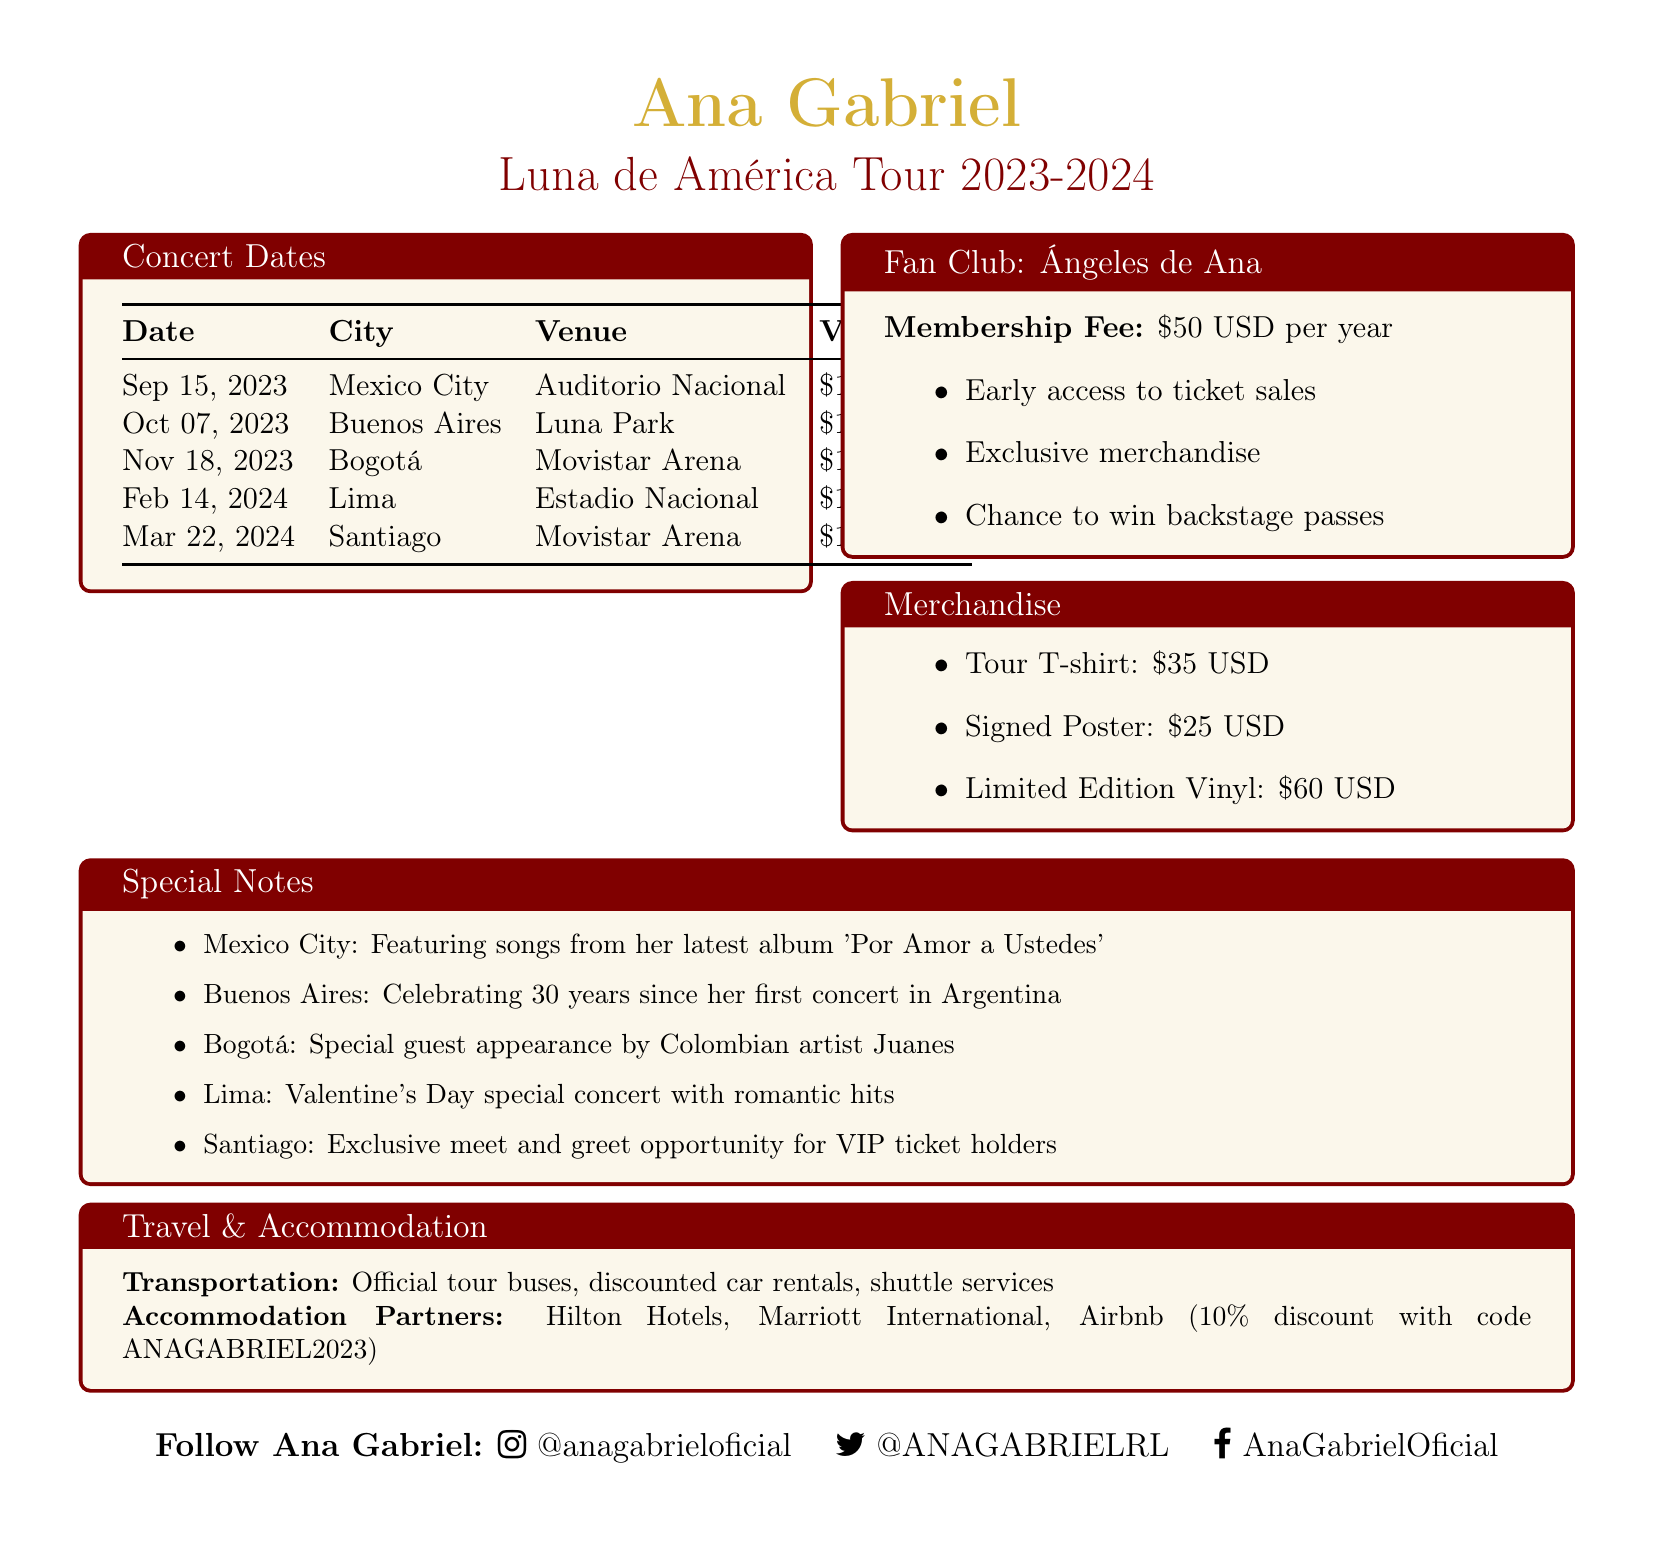What is the name of the tour? The tour is named "Luna de América Tour 2023-2024."
Answer: Luna de América Tour 2023-2024 When is the concert in Buenos Aires? The concert in Buenos Aires is scheduled for October 7, 2023.
Answer: October 7, 2023 What is the venue for the concert in Bogotá? The venue for the concert in Bogotá is "Movistar Arena."
Answer: Movistar Arena How much is a VIP ticket for the concert in Lima? The VIP ticket for the concert in Lima costs $140 USD.
Answer: $140 USD Which special guest will perform in Bogotá? The special guest in Bogotá is Colombian artist Juanes.
Answer: Juanes What special event is happening during the concert in Buenos Aires? The concert in Buenos Aires is celebrating 30 years since Ana Gabriel's first concert in Argentina.
Answer: Celebrating 30 years What is included with the membership of the fan club? The fan club offers early access to ticket sales, exclusive merchandise, and a chance to win backstage passes.
Answer: Early access to ticket sales, exclusive merchandise, chance to win backstage passes Which hotel provides a discount for fans? Airbnb offers a 10% discount for fans using a particular promo code.
Answer: Airbnb What is the price of the signed poster merchandise? The signed poster is priced at $25 USD.
Answer: $25 USD 